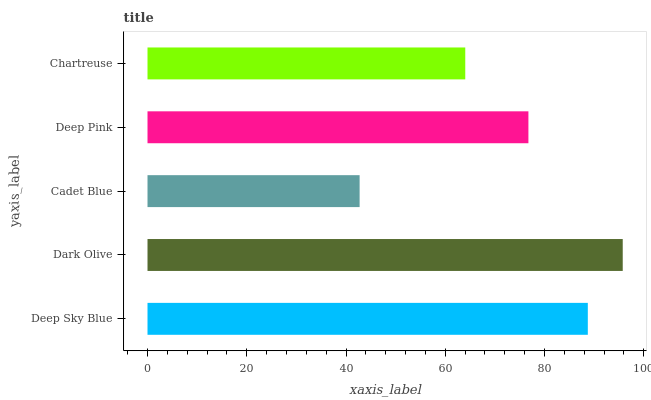Is Cadet Blue the minimum?
Answer yes or no. Yes. Is Dark Olive the maximum?
Answer yes or no. Yes. Is Dark Olive the minimum?
Answer yes or no. No. Is Cadet Blue the maximum?
Answer yes or no. No. Is Dark Olive greater than Cadet Blue?
Answer yes or no. Yes. Is Cadet Blue less than Dark Olive?
Answer yes or no. Yes. Is Cadet Blue greater than Dark Olive?
Answer yes or no. No. Is Dark Olive less than Cadet Blue?
Answer yes or no. No. Is Deep Pink the high median?
Answer yes or no. Yes. Is Deep Pink the low median?
Answer yes or no. Yes. Is Dark Olive the high median?
Answer yes or no. No. Is Deep Sky Blue the low median?
Answer yes or no. No. 